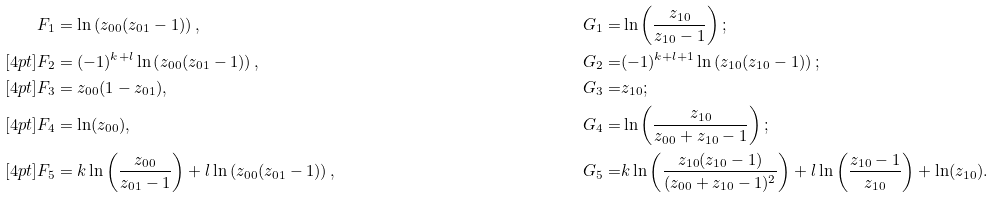<formula> <loc_0><loc_0><loc_500><loc_500>F _ { 1 } & = \ln \left ( z _ { 0 0 } ( z _ { 0 1 } - 1 ) \right ) , & G _ { 1 } = & \ln \left ( \frac { z _ { 1 0 } } { z _ { 1 0 } - 1 } \right ) ; & \\ [ 4 p t ] F _ { 2 } & = ( - 1 ) ^ { k + l } \ln \left ( z _ { 0 0 } ( z _ { 0 1 } - 1 ) \right ) , & G _ { 2 } = & ( - 1 ) ^ { k + l + 1 } \ln \left ( z _ { 1 0 } ( z _ { 1 0 } - 1 ) \right ) ; & \\ [ 4 p t ] F _ { 3 } & = z _ { 0 0 } ( 1 - z _ { 0 1 } ) , & G _ { 3 } = & z _ { 1 0 } ; & \\ [ 4 p t ] F _ { 4 } & = \ln ( z _ { 0 0 } ) , & G _ { 4 } = & \ln \left ( \frac { z _ { 1 0 } } { z _ { 0 0 } + z _ { 1 0 } - 1 } \right ) ; & \\ [ 4 p t ] F _ { 5 } & = k \ln \left ( \frac { z _ { 0 0 } } { z _ { 0 1 } - 1 } \right ) + l \ln \left ( z _ { 0 0 } ( z _ { 0 1 } - 1 ) \right ) , \quad & G _ { 5 } = & k \ln \left ( \frac { z _ { 1 0 } ( z _ { 1 0 } - 1 ) } { ( z _ { 0 0 } + z _ { 1 0 } - 1 ) ^ { 2 } } \right ) + l \ln \left ( \frac { z _ { 1 0 } - 1 } { z _ { 1 0 } } \right ) + \ln ( z _ { 1 0 } ) . &</formula> 